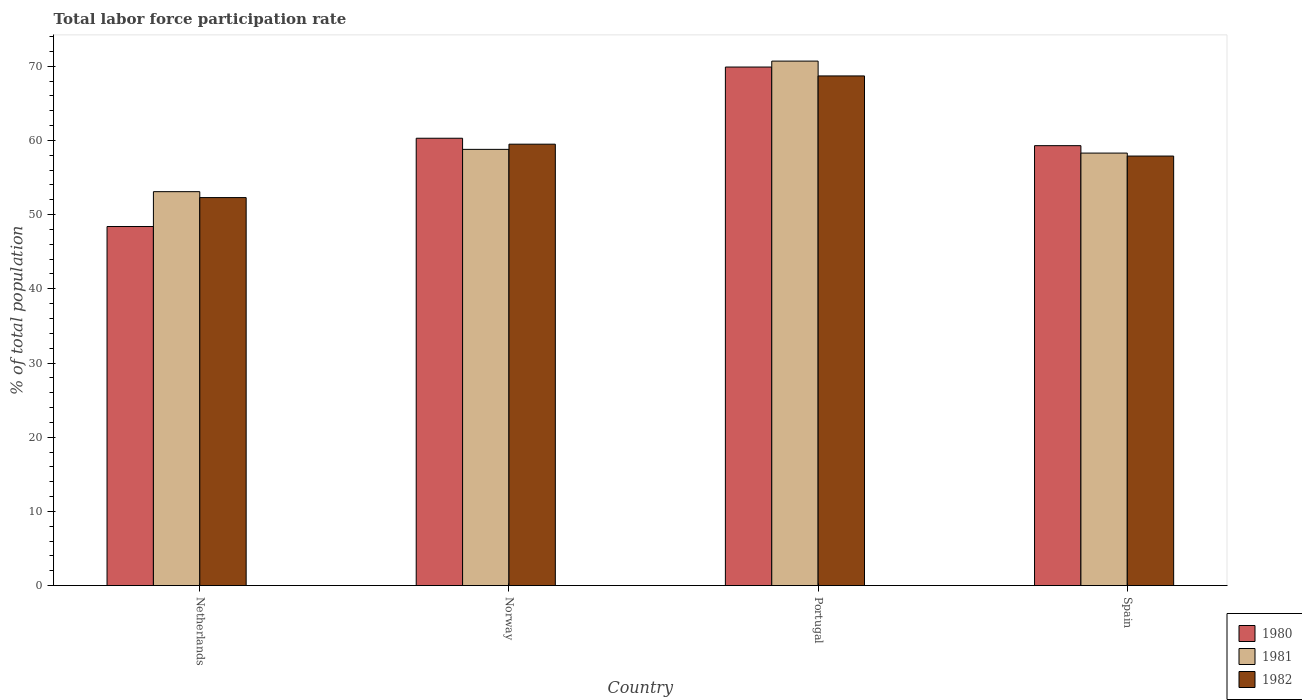Are the number of bars per tick equal to the number of legend labels?
Give a very brief answer. Yes. How many bars are there on the 1st tick from the left?
Your answer should be very brief. 3. What is the total labor force participation rate in 1981 in Spain?
Your answer should be very brief. 58.3. Across all countries, what is the maximum total labor force participation rate in 1981?
Give a very brief answer. 70.7. Across all countries, what is the minimum total labor force participation rate in 1980?
Give a very brief answer. 48.4. In which country was the total labor force participation rate in 1980 maximum?
Ensure brevity in your answer.  Portugal. What is the total total labor force participation rate in 1980 in the graph?
Offer a very short reply. 237.9. What is the difference between the total labor force participation rate in 1982 in Portugal and that in Spain?
Provide a succinct answer. 10.8. What is the difference between the total labor force participation rate in 1980 in Portugal and the total labor force participation rate in 1982 in Netherlands?
Give a very brief answer. 17.6. What is the average total labor force participation rate in 1980 per country?
Provide a succinct answer. 59.48. What is the difference between the total labor force participation rate of/in 1980 and total labor force participation rate of/in 1981 in Norway?
Your answer should be compact. 1.5. In how many countries, is the total labor force participation rate in 1981 greater than 68 %?
Provide a short and direct response. 1. What is the ratio of the total labor force participation rate in 1980 in Netherlands to that in Portugal?
Provide a succinct answer. 0.69. What is the difference between the highest and the second highest total labor force participation rate in 1982?
Keep it short and to the point. -1.6. What is the difference between the highest and the lowest total labor force participation rate in 1980?
Offer a very short reply. 21.5. In how many countries, is the total labor force participation rate in 1982 greater than the average total labor force participation rate in 1982 taken over all countries?
Keep it short and to the point. 1. Is the sum of the total labor force participation rate in 1980 in Netherlands and Portugal greater than the maximum total labor force participation rate in 1982 across all countries?
Ensure brevity in your answer.  Yes. What does the 1st bar from the left in Norway represents?
Provide a succinct answer. 1980. What does the 2nd bar from the right in Spain represents?
Your answer should be very brief. 1981. Are all the bars in the graph horizontal?
Your answer should be compact. No. Are the values on the major ticks of Y-axis written in scientific E-notation?
Provide a short and direct response. No. Does the graph contain grids?
Make the answer very short. No. How many legend labels are there?
Give a very brief answer. 3. What is the title of the graph?
Ensure brevity in your answer.  Total labor force participation rate. What is the label or title of the Y-axis?
Your answer should be compact. % of total population. What is the % of total population of 1980 in Netherlands?
Offer a terse response. 48.4. What is the % of total population in 1981 in Netherlands?
Your response must be concise. 53.1. What is the % of total population in 1982 in Netherlands?
Provide a short and direct response. 52.3. What is the % of total population in 1980 in Norway?
Your answer should be very brief. 60.3. What is the % of total population in 1981 in Norway?
Provide a succinct answer. 58.8. What is the % of total population in 1982 in Norway?
Your answer should be very brief. 59.5. What is the % of total population of 1980 in Portugal?
Ensure brevity in your answer.  69.9. What is the % of total population of 1981 in Portugal?
Provide a short and direct response. 70.7. What is the % of total population of 1982 in Portugal?
Make the answer very short. 68.7. What is the % of total population in 1980 in Spain?
Offer a terse response. 59.3. What is the % of total population in 1981 in Spain?
Give a very brief answer. 58.3. What is the % of total population of 1982 in Spain?
Make the answer very short. 57.9. Across all countries, what is the maximum % of total population of 1980?
Make the answer very short. 69.9. Across all countries, what is the maximum % of total population of 1981?
Offer a terse response. 70.7. Across all countries, what is the maximum % of total population of 1982?
Provide a succinct answer. 68.7. Across all countries, what is the minimum % of total population of 1980?
Your answer should be compact. 48.4. Across all countries, what is the minimum % of total population in 1981?
Ensure brevity in your answer.  53.1. Across all countries, what is the minimum % of total population of 1982?
Offer a very short reply. 52.3. What is the total % of total population of 1980 in the graph?
Provide a succinct answer. 237.9. What is the total % of total population of 1981 in the graph?
Offer a very short reply. 240.9. What is the total % of total population of 1982 in the graph?
Provide a short and direct response. 238.4. What is the difference between the % of total population of 1980 in Netherlands and that in Norway?
Offer a terse response. -11.9. What is the difference between the % of total population of 1982 in Netherlands and that in Norway?
Provide a succinct answer. -7.2. What is the difference between the % of total population of 1980 in Netherlands and that in Portugal?
Offer a very short reply. -21.5. What is the difference between the % of total population of 1981 in Netherlands and that in Portugal?
Ensure brevity in your answer.  -17.6. What is the difference between the % of total population of 1982 in Netherlands and that in Portugal?
Make the answer very short. -16.4. What is the difference between the % of total population of 1980 in Netherlands and that in Spain?
Provide a succinct answer. -10.9. What is the difference between the % of total population of 1981 in Netherlands and that in Spain?
Provide a succinct answer. -5.2. What is the difference between the % of total population in 1982 in Netherlands and that in Spain?
Keep it short and to the point. -5.6. What is the difference between the % of total population in 1981 in Norway and that in Portugal?
Your answer should be compact. -11.9. What is the difference between the % of total population of 1982 in Norway and that in Portugal?
Give a very brief answer. -9.2. What is the difference between the % of total population of 1981 in Norway and that in Spain?
Offer a very short reply. 0.5. What is the difference between the % of total population in 1982 in Norway and that in Spain?
Your response must be concise. 1.6. What is the difference between the % of total population of 1980 in Portugal and that in Spain?
Keep it short and to the point. 10.6. What is the difference between the % of total population of 1980 in Netherlands and the % of total population of 1982 in Norway?
Keep it short and to the point. -11.1. What is the difference between the % of total population of 1981 in Netherlands and the % of total population of 1982 in Norway?
Offer a terse response. -6.4. What is the difference between the % of total population in 1980 in Netherlands and the % of total population in 1981 in Portugal?
Offer a very short reply. -22.3. What is the difference between the % of total population of 1980 in Netherlands and the % of total population of 1982 in Portugal?
Offer a terse response. -20.3. What is the difference between the % of total population of 1981 in Netherlands and the % of total population of 1982 in Portugal?
Make the answer very short. -15.6. What is the difference between the % of total population in 1980 in Netherlands and the % of total population in 1982 in Spain?
Your answer should be compact. -9.5. What is the difference between the % of total population of 1981 in Netherlands and the % of total population of 1982 in Spain?
Make the answer very short. -4.8. What is the difference between the % of total population in 1980 in Norway and the % of total population in 1981 in Portugal?
Provide a short and direct response. -10.4. What is the difference between the % of total population of 1980 in Norway and the % of total population of 1981 in Spain?
Make the answer very short. 2. What is the difference between the % of total population in 1980 in Norway and the % of total population in 1982 in Spain?
Your answer should be compact. 2.4. What is the difference between the % of total population of 1980 in Portugal and the % of total population of 1981 in Spain?
Your response must be concise. 11.6. What is the average % of total population in 1980 per country?
Keep it short and to the point. 59.48. What is the average % of total population of 1981 per country?
Your answer should be compact. 60.23. What is the average % of total population of 1982 per country?
Ensure brevity in your answer.  59.6. What is the difference between the % of total population of 1980 and % of total population of 1982 in Norway?
Your answer should be compact. 0.8. What is the difference between the % of total population of 1981 and % of total population of 1982 in Norway?
Your answer should be compact. -0.7. What is the difference between the % of total population of 1980 and % of total population of 1981 in Portugal?
Your answer should be very brief. -0.8. What is the difference between the % of total population in 1981 and % of total population in 1982 in Portugal?
Give a very brief answer. 2. What is the difference between the % of total population of 1980 and % of total population of 1981 in Spain?
Ensure brevity in your answer.  1. What is the difference between the % of total population in 1980 and % of total population in 1982 in Spain?
Give a very brief answer. 1.4. What is the ratio of the % of total population of 1980 in Netherlands to that in Norway?
Offer a terse response. 0.8. What is the ratio of the % of total population in 1981 in Netherlands to that in Norway?
Your response must be concise. 0.9. What is the ratio of the % of total population of 1982 in Netherlands to that in Norway?
Your response must be concise. 0.88. What is the ratio of the % of total population in 1980 in Netherlands to that in Portugal?
Offer a terse response. 0.69. What is the ratio of the % of total population in 1981 in Netherlands to that in Portugal?
Provide a succinct answer. 0.75. What is the ratio of the % of total population in 1982 in Netherlands to that in Portugal?
Give a very brief answer. 0.76. What is the ratio of the % of total population of 1980 in Netherlands to that in Spain?
Provide a short and direct response. 0.82. What is the ratio of the % of total population in 1981 in Netherlands to that in Spain?
Offer a terse response. 0.91. What is the ratio of the % of total population in 1982 in Netherlands to that in Spain?
Ensure brevity in your answer.  0.9. What is the ratio of the % of total population in 1980 in Norway to that in Portugal?
Give a very brief answer. 0.86. What is the ratio of the % of total population of 1981 in Norway to that in Portugal?
Ensure brevity in your answer.  0.83. What is the ratio of the % of total population in 1982 in Norway to that in Portugal?
Provide a succinct answer. 0.87. What is the ratio of the % of total population in 1980 in Norway to that in Spain?
Make the answer very short. 1.02. What is the ratio of the % of total population in 1981 in Norway to that in Spain?
Give a very brief answer. 1.01. What is the ratio of the % of total population in 1982 in Norway to that in Spain?
Your answer should be very brief. 1.03. What is the ratio of the % of total population in 1980 in Portugal to that in Spain?
Ensure brevity in your answer.  1.18. What is the ratio of the % of total population in 1981 in Portugal to that in Spain?
Provide a short and direct response. 1.21. What is the ratio of the % of total population in 1982 in Portugal to that in Spain?
Provide a short and direct response. 1.19. What is the difference between the highest and the second highest % of total population of 1980?
Your response must be concise. 9.6. What is the difference between the highest and the lowest % of total population in 1980?
Your response must be concise. 21.5. 